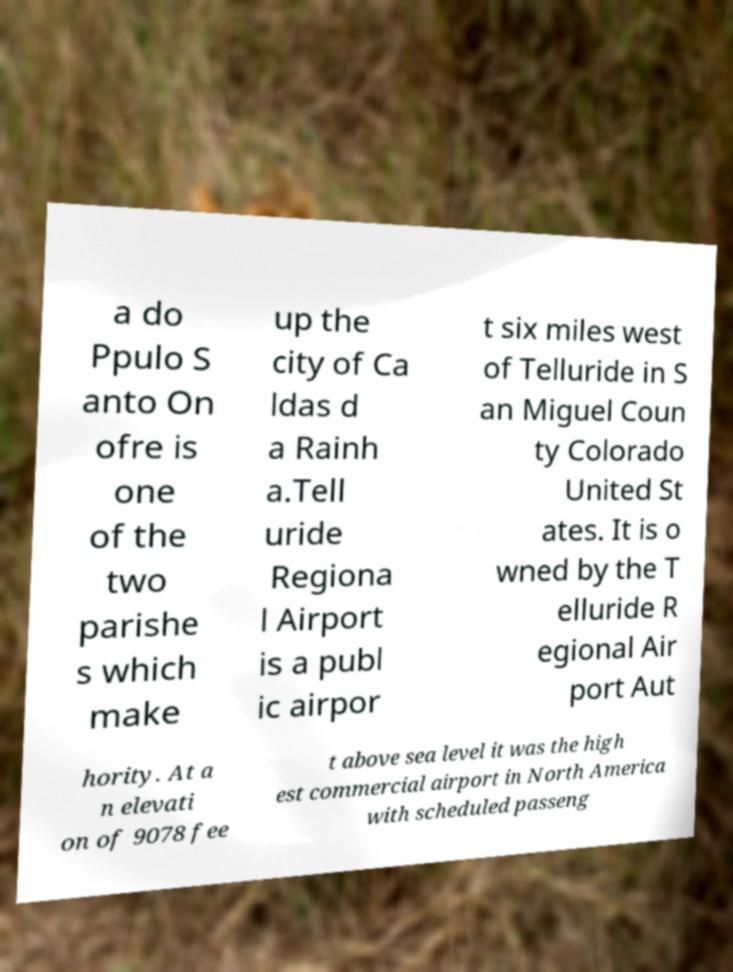Can you read and provide the text displayed in the image?This photo seems to have some interesting text. Can you extract and type it out for me? a do Ppulo S anto On ofre is one of the two parishe s which make up the city of Ca ldas d a Rainh a.Tell uride Regiona l Airport is a publ ic airpor t six miles west of Telluride in S an Miguel Coun ty Colorado United St ates. It is o wned by the T elluride R egional Air port Aut hority. At a n elevati on of 9078 fee t above sea level it was the high est commercial airport in North America with scheduled passeng 